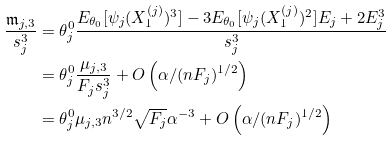Convert formula to latex. <formula><loc_0><loc_0><loc_500><loc_500>\frac { \mathfrak { m } _ { j , 3 } } { s _ { j } ^ { 3 } } & = \theta _ { j } ^ { 0 } \frac { E _ { \theta _ { 0 } } [ \psi _ { j } ( X _ { 1 } ^ { ( j ) } ) ^ { 3 } ] - 3 E _ { \theta _ { 0 } } [ \psi _ { j } ( X _ { 1 } ^ { ( j ) } ) ^ { 2 } ] E _ { j } + 2 E _ { j } ^ { 3 } } { s _ { j } ^ { 3 } } \\ & = \theta _ { j } ^ { 0 } \frac { \mu _ { j , 3 } } { F _ { j } s _ { j } ^ { 3 } } + O \left ( \alpha / ( n F _ { j } ) ^ { 1 / 2 } \right ) \\ & = \theta _ { j } ^ { 0 } \mu _ { j , 3 } n ^ { 3 / 2 } \sqrt { F _ { j } } \alpha ^ { - 3 } + O \left ( \alpha / ( n F _ { j } ) ^ { 1 / 2 } \right )</formula> 